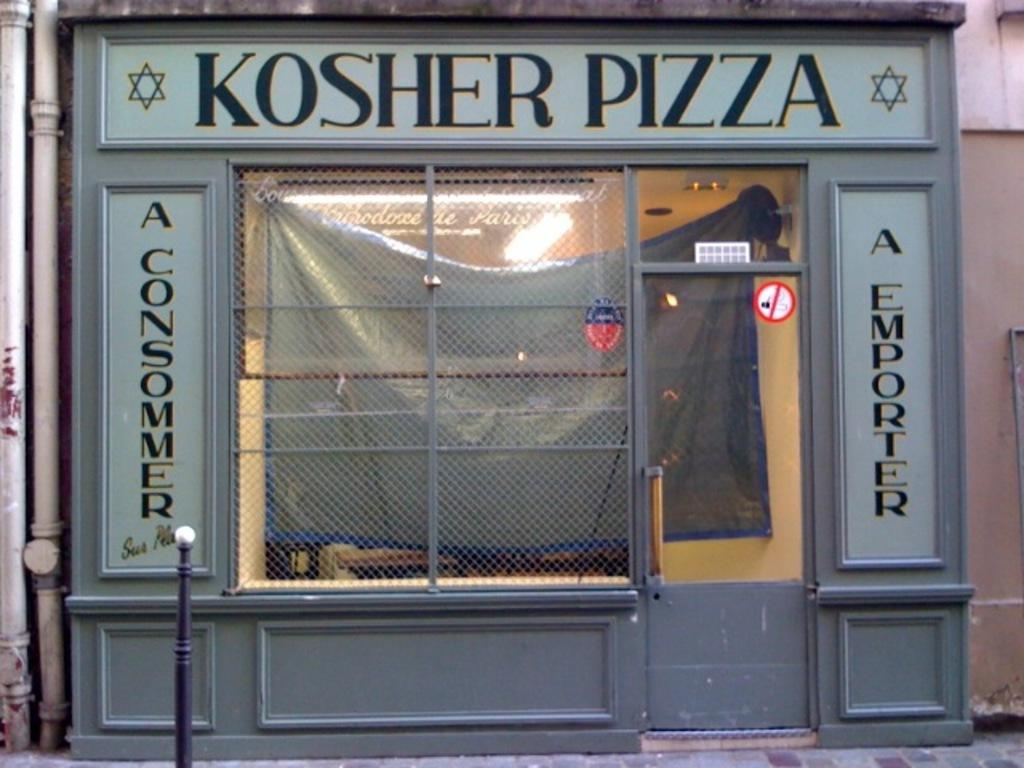What type of establishment is depicted in the image? The image appears to depict a store. Can you describe the entrance to the store? There is a door on the store. What is written or displayed on the door or store? There is text on the door or store. What is on the right side of the image? There is a wall on the right side of the image. What type of infrastructure is visible in the image? There are pipes visible in the image. What is on the left side of the image? There is a small pole on the left side of the image. In which direction does the store face, north or south? The image does not provide information about the direction the store faces, so it cannot be determined from the image. How does the store sort its inventory? The image does not provide information about how the store sorts its inventory, so it cannot be determined from the image. 